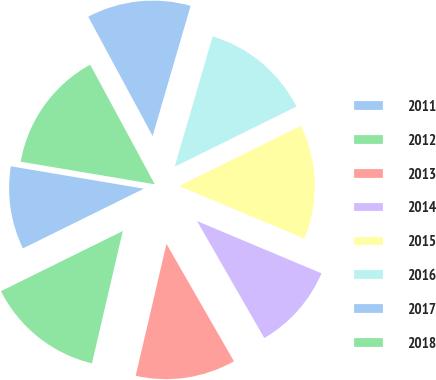Convert chart to OTSL. <chart><loc_0><loc_0><loc_500><loc_500><pie_chart><fcel>2011<fcel>2012<fcel>2013<fcel>2014<fcel>2015<fcel>2016<fcel>2017<fcel>2018<nl><fcel>9.96%<fcel>14.05%<fcel>11.95%<fcel>10.37%<fcel>13.63%<fcel>13.18%<fcel>12.4%<fcel>14.46%<nl></chart> 